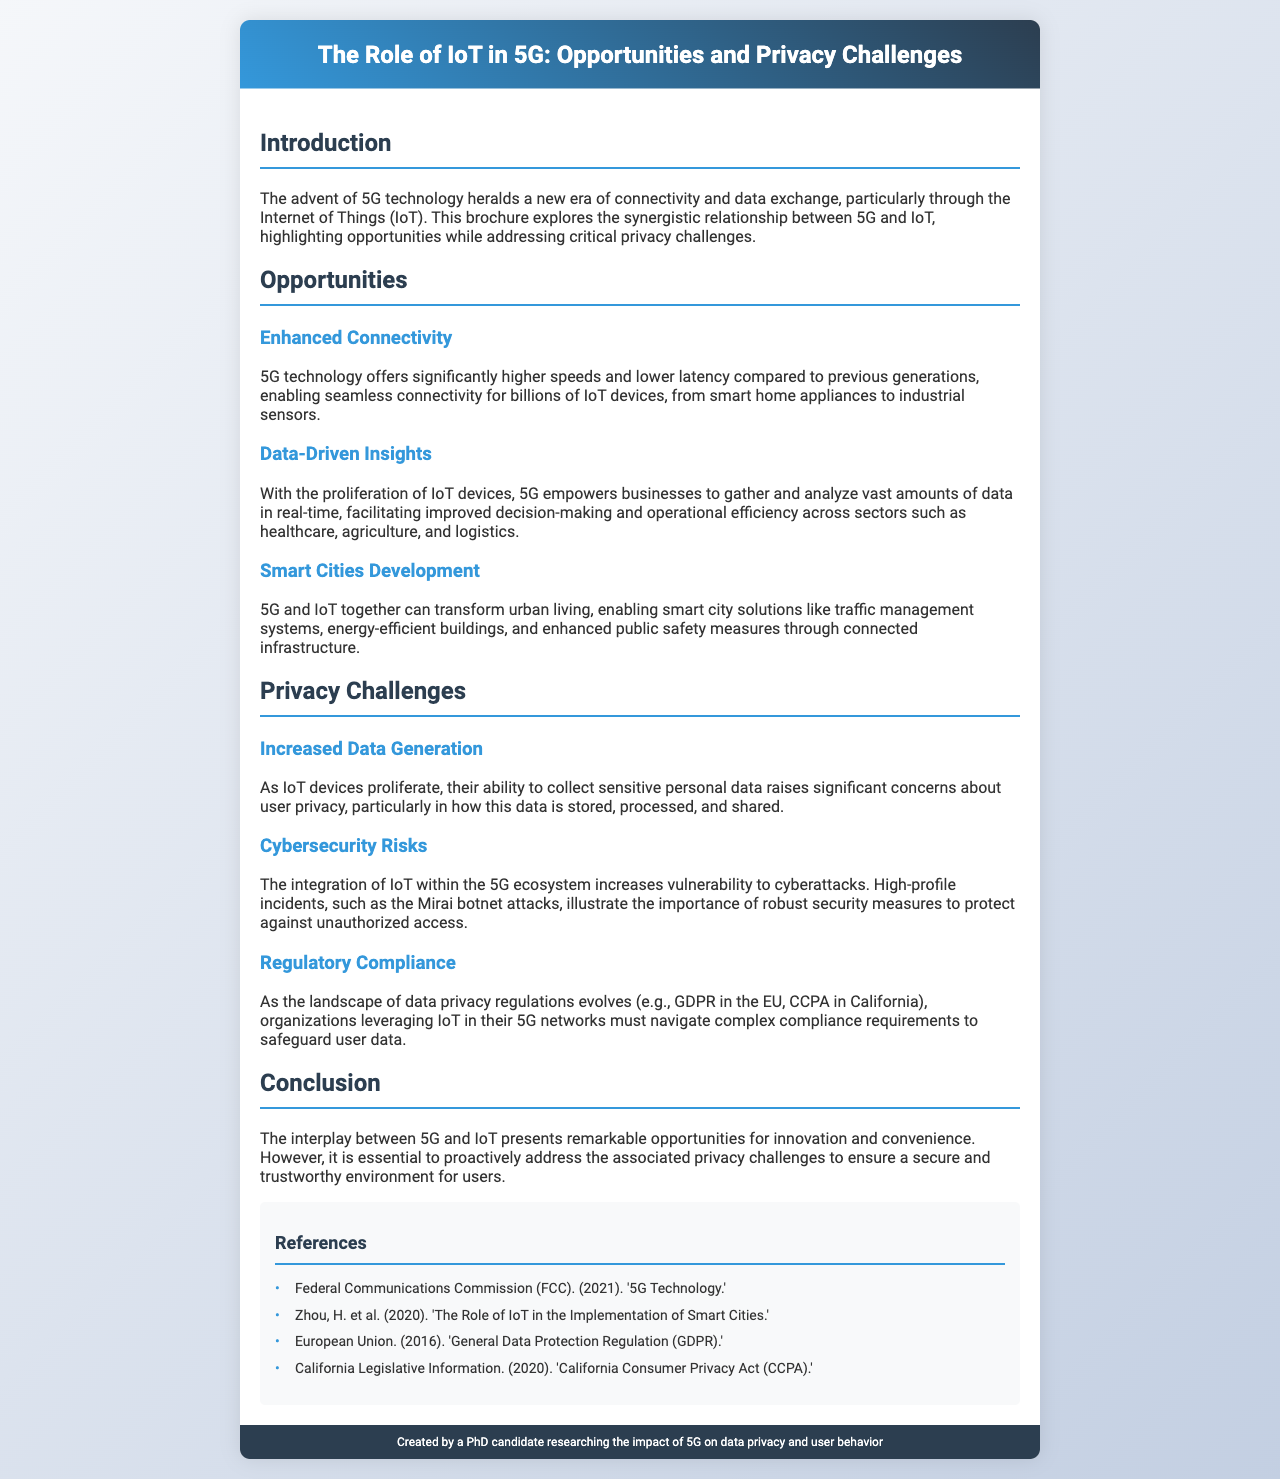What is the main topic of the brochure? The brochure focuses on the relationship between IoT and 5G, highlighting opportunities and privacy challenges.
Answer: The Role of IoT in 5G: Opportunities and Privacy Challenges What technology offers higher speeds and lower latency? The brochure mentions that 5G technology enables higher speeds and lower latency compared to previous generations.
Answer: 5G technology Which area of application is enhanced by data-driven insights from IoT? The brochure lists healthcare, agriculture, and logistics as sectors benefiting from data-driven insights enabled by 5G and IoT.
Answer: Healthcare, agriculture, and logistics What is a key privacy concern associated with IoT proliferation? The brochure highlights that the ability of IoT devices to collect sensitive personal data raises significant concerns about user privacy.
Answer: User privacy What year was the General Data Protection Regulation (GDPR) established? The brochure references the GDPR as being enacted in the year 2016.
Answer: 2016 What significant event illustrates cybersecurity risks in the IoT space? The brochure mentions the Mirai botnet attacks as a high-profile incident illustrating cybersecurity risks.
Answer: Mirai botnet attacks What is one of the opportunities presented by 5G and IoT for urban areas? The brochure states that 5G and IoT can transform urban living through smart city solutions.
Answer: Smart city solutions Which regulatory compliance is mentioned alongside the evolution of privacy regulations? The California Consumer Privacy Act (CCPA) is mentioned in conjunction with evolving privacy regulations.
Answer: California Consumer Privacy Act (CCPA) Who created the brochure? The footer credits the creation of the brochure to a PhD candidate researching the impact of 5G on data privacy and user behavior.
Answer: A PhD candidate 